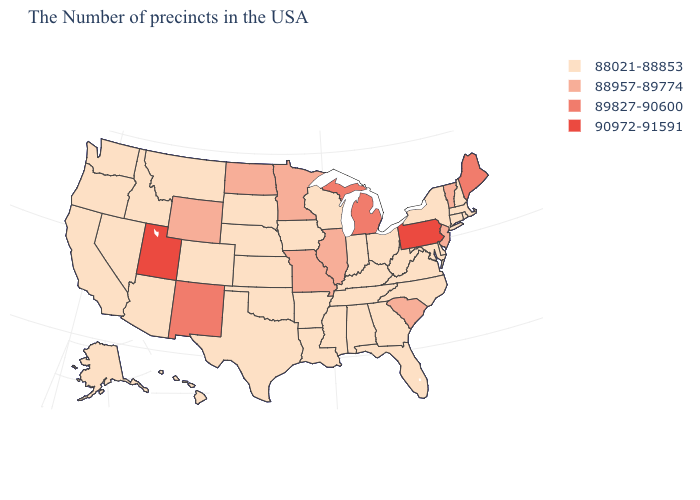What is the lowest value in states that border Ohio?
Give a very brief answer. 88021-88853. Name the states that have a value in the range 88021-88853?
Keep it brief. Massachusetts, Rhode Island, New Hampshire, Connecticut, New York, Delaware, Maryland, Virginia, North Carolina, West Virginia, Ohio, Florida, Georgia, Kentucky, Indiana, Alabama, Tennessee, Wisconsin, Mississippi, Louisiana, Arkansas, Iowa, Kansas, Nebraska, Oklahoma, Texas, South Dakota, Colorado, Montana, Arizona, Idaho, Nevada, California, Washington, Oregon, Alaska, Hawaii. Name the states that have a value in the range 88957-89774?
Keep it brief. Vermont, New Jersey, South Carolina, Illinois, Missouri, Minnesota, North Dakota, Wyoming. Name the states that have a value in the range 89827-90600?
Write a very short answer. Maine, Michigan, New Mexico. What is the value of North Dakota?
Quick response, please. 88957-89774. Name the states that have a value in the range 89827-90600?
Write a very short answer. Maine, Michigan, New Mexico. What is the lowest value in the MidWest?
Give a very brief answer. 88021-88853. Name the states that have a value in the range 88957-89774?
Write a very short answer. Vermont, New Jersey, South Carolina, Illinois, Missouri, Minnesota, North Dakota, Wyoming. Does Wyoming have the lowest value in the West?
Short answer required. No. What is the value of Wyoming?
Quick response, please. 88957-89774. What is the highest value in the USA?
Answer briefly. 90972-91591. Does Utah have the highest value in the USA?
Write a very short answer. Yes. What is the lowest value in the USA?
Write a very short answer. 88021-88853. 